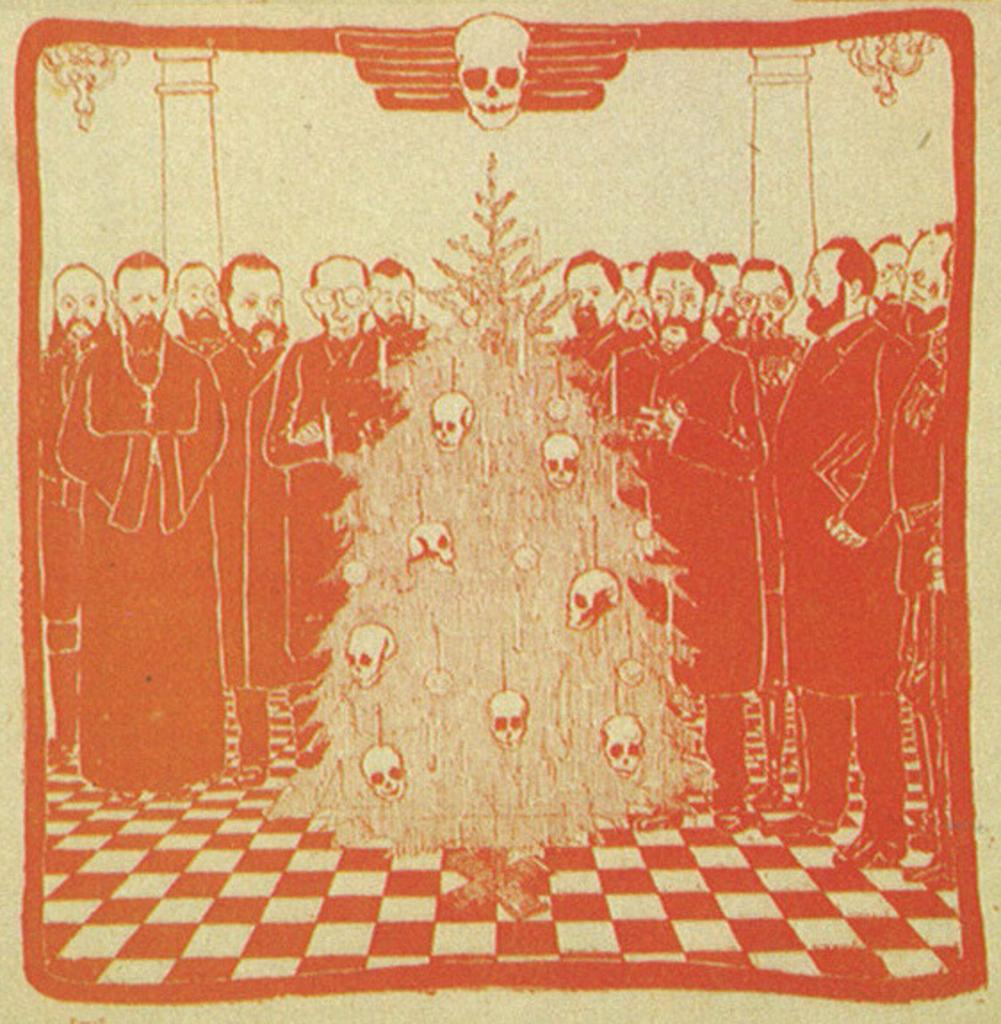What is featured on the poster in the image? The poster contains images of men standing. Where are the men standing in the poster? The men are standing on the floor in the poster. What else can be seen in the image besides the poster? There is a tree in the image, and skulls are on the tree. What is the purpose of the group of people standing on the floor in the image? There is no group of people standing on the floor in the image; the men are standing in the poster. What type of floor is visible in the image? There is no floor visible in the image, as the men are standing in the poster, not in the actual scene. 